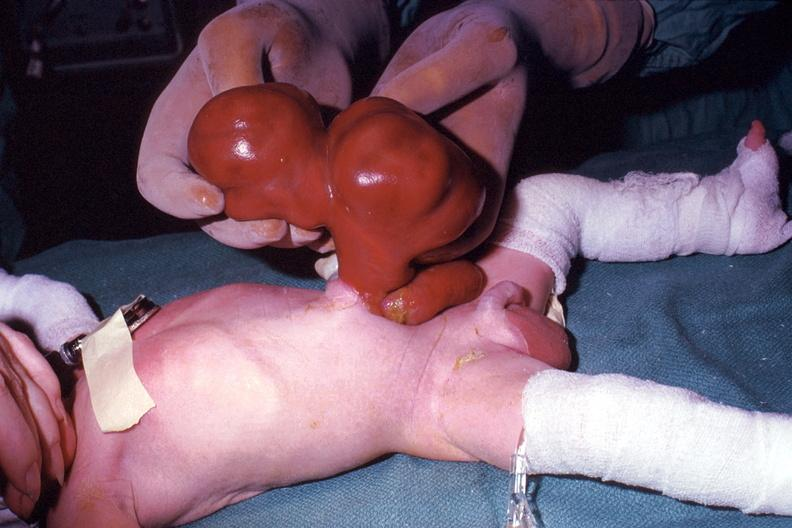s omentum present?
Answer the question using a single word or phrase. No 